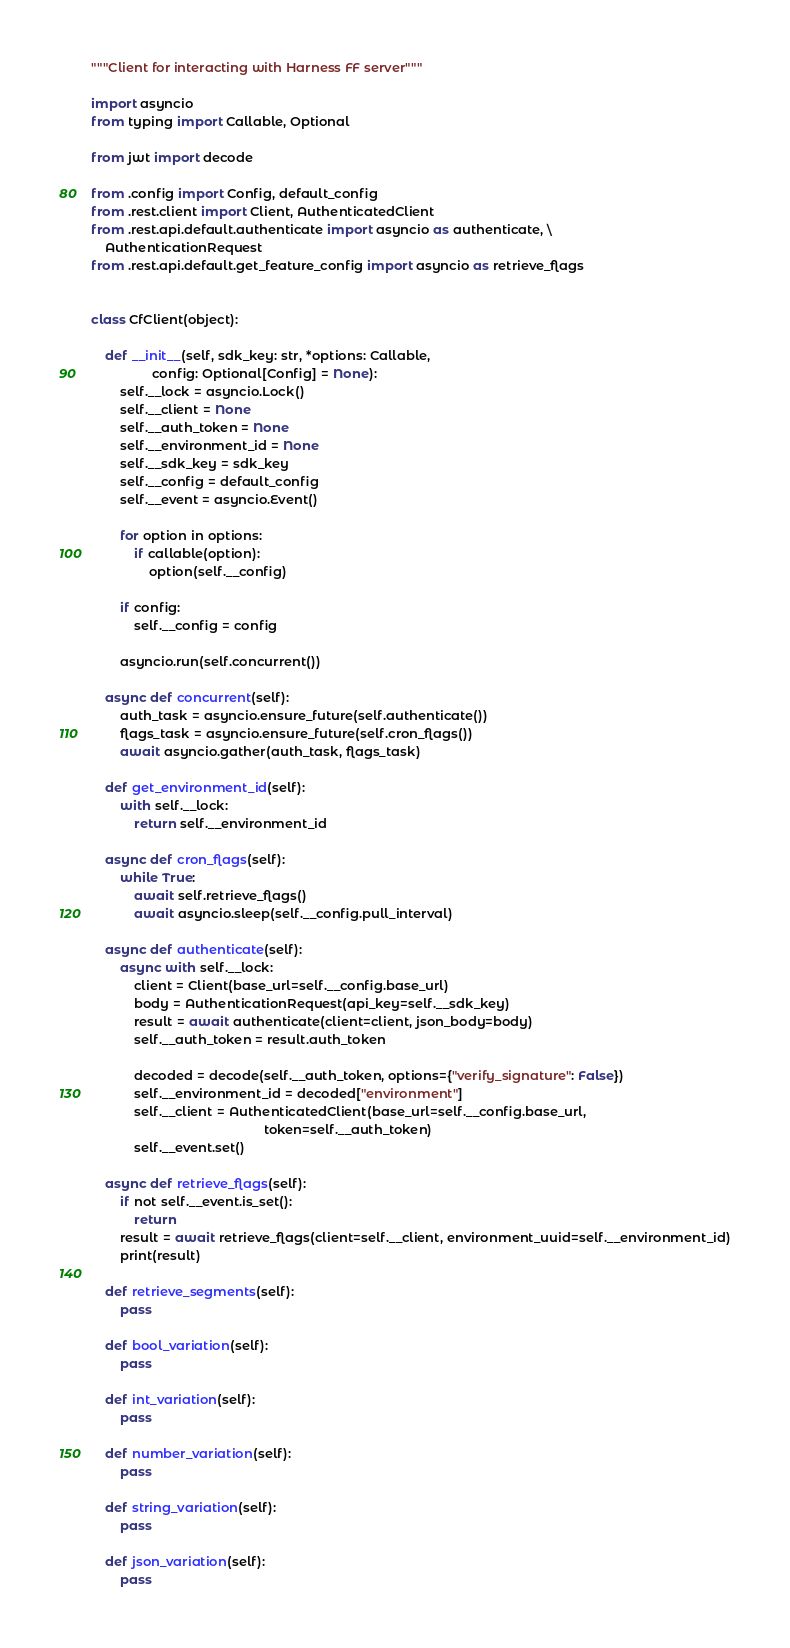Convert code to text. <code><loc_0><loc_0><loc_500><loc_500><_Python_>"""Client for interacting with Harness FF server"""

import asyncio
from typing import Callable, Optional

from jwt import decode

from .config import Config, default_config
from .rest.client import Client, AuthenticatedClient
from .rest.api.default.authenticate import asyncio as authenticate, \
    AuthenticationRequest
from .rest.api.default.get_feature_config import asyncio as retrieve_flags


class CfClient(object):

    def __init__(self, sdk_key: str, *options: Callable,
                 config: Optional[Config] = None):
        self.__lock = asyncio.Lock()
        self.__client = None
        self.__auth_token = None
        self.__environment_id = None
        self.__sdk_key = sdk_key
        self.__config = default_config
        self.__event = asyncio.Event()

        for option in options:
            if callable(option):
                option(self.__config)

        if config:
            self.__config = config

        asyncio.run(self.concurrent())

    async def concurrent(self):
        auth_task = asyncio.ensure_future(self.authenticate())
        flags_task = asyncio.ensure_future(self.cron_flags())
        await asyncio.gather(auth_task, flags_task)

    def get_environment_id(self):
        with self.__lock:
            return self.__environment_id

    async def cron_flags(self):
        while True:
            await self.retrieve_flags()
            await asyncio.sleep(self.__config.pull_interval)

    async def authenticate(self):
        async with self.__lock:
            client = Client(base_url=self.__config.base_url)
            body = AuthenticationRequest(api_key=self.__sdk_key)
            result = await authenticate(client=client, json_body=body)
            self.__auth_token = result.auth_token

            decoded = decode(self.__auth_token, options={"verify_signature": False})
            self.__environment_id = decoded["environment"]
            self.__client = AuthenticatedClient(base_url=self.__config.base_url,
                                                token=self.__auth_token)
            self.__event.set()

    async def retrieve_flags(self):
        if not self.__event.is_set():
            return
        result = await retrieve_flags(client=self.__client, environment_uuid=self.__environment_id)
        print(result)

    def retrieve_segments(self):
        pass

    def bool_variation(self):
        pass

    def int_variation(self):
        pass

    def number_variation(self):
        pass

    def string_variation(self):
        pass

    def json_variation(self):
        pass
</code> 